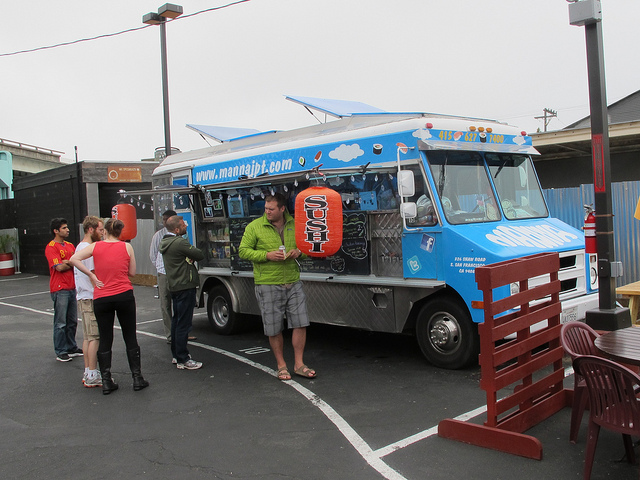Read all the text in this image. www.mannaipt.com SUSHI 3 4156277400 